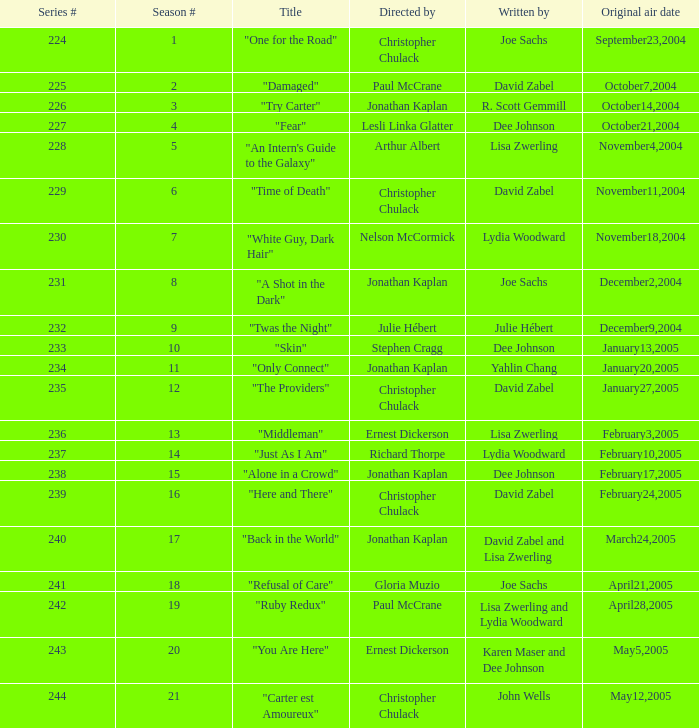Who was the director of episode 236 in the series? Ernest Dickerson. Can you parse all the data within this table? {'header': ['Series #', 'Season #', 'Title', 'Directed by', 'Written by', 'Original air date'], 'rows': [['224', '1', '"One for the Road"', 'Christopher Chulack', 'Joe Sachs', 'September23,2004'], ['225', '2', '"Damaged"', 'Paul McCrane', 'David Zabel', 'October7,2004'], ['226', '3', '"Try Carter"', 'Jonathan Kaplan', 'R. Scott Gemmill', 'October14,2004'], ['227', '4', '"Fear"', 'Lesli Linka Glatter', 'Dee Johnson', 'October21,2004'], ['228', '5', '"An Intern\'s Guide to the Galaxy"', 'Arthur Albert', 'Lisa Zwerling', 'November4,2004'], ['229', '6', '"Time of Death"', 'Christopher Chulack', 'David Zabel', 'November11,2004'], ['230', '7', '"White Guy, Dark Hair"', 'Nelson McCormick', 'Lydia Woodward', 'November18,2004'], ['231', '8', '"A Shot in the Dark"', 'Jonathan Kaplan', 'Joe Sachs', 'December2,2004'], ['232', '9', '"Twas the Night"', 'Julie Hébert', 'Julie Hébert', 'December9,2004'], ['233', '10', '"Skin"', 'Stephen Cragg', 'Dee Johnson', 'January13,2005'], ['234', '11', '"Only Connect"', 'Jonathan Kaplan', 'Yahlin Chang', 'January20,2005'], ['235', '12', '"The Providers"', 'Christopher Chulack', 'David Zabel', 'January27,2005'], ['236', '13', '"Middleman"', 'Ernest Dickerson', 'Lisa Zwerling', 'February3,2005'], ['237', '14', '"Just As I Am"', 'Richard Thorpe', 'Lydia Woodward', 'February10,2005'], ['238', '15', '"Alone in a Crowd"', 'Jonathan Kaplan', 'Dee Johnson', 'February17,2005'], ['239', '16', '"Here and There"', 'Christopher Chulack', 'David Zabel', 'February24,2005'], ['240', '17', '"Back in the World"', 'Jonathan Kaplan', 'David Zabel and Lisa Zwerling', 'March24,2005'], ['241', '18', '"Refusal of Care"', 'Gloria Muzio', 'Joe Sachs', 'April21,2005'], ['242', '19', '"Ruby Redux"', 'Paul McCrane', 'Lisa Zwerling and Lydia Woodward', 'April28,2005'], ['243', '20', '"You Are Here"', 'Ernest Dickerson', 'Karen Maser and Dee Johnson', 'May5,2005'], ['244', '21', '"Carter est Amoureux"', 'Christopher Chulack', 'John Wells', 'May12,2005']]} 